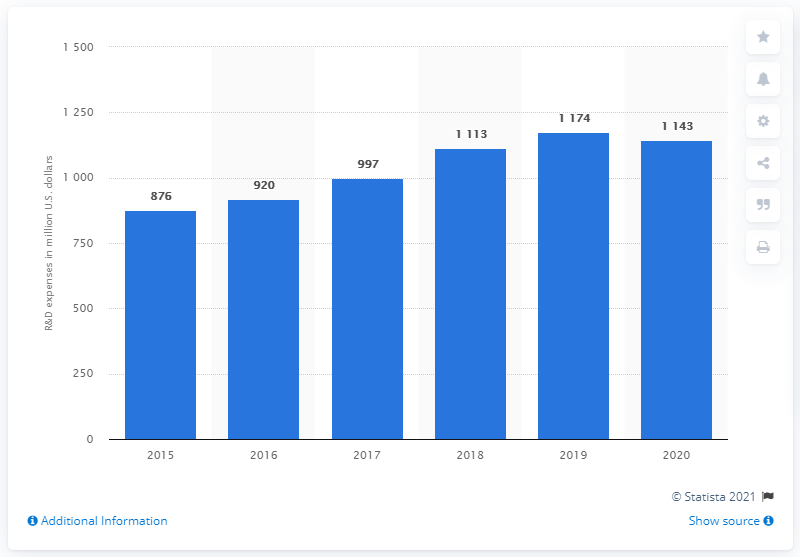Indicate a few pertinent items in this graphic. Boston Scientific spent approximately $1,143 million on research and development in 2020. 